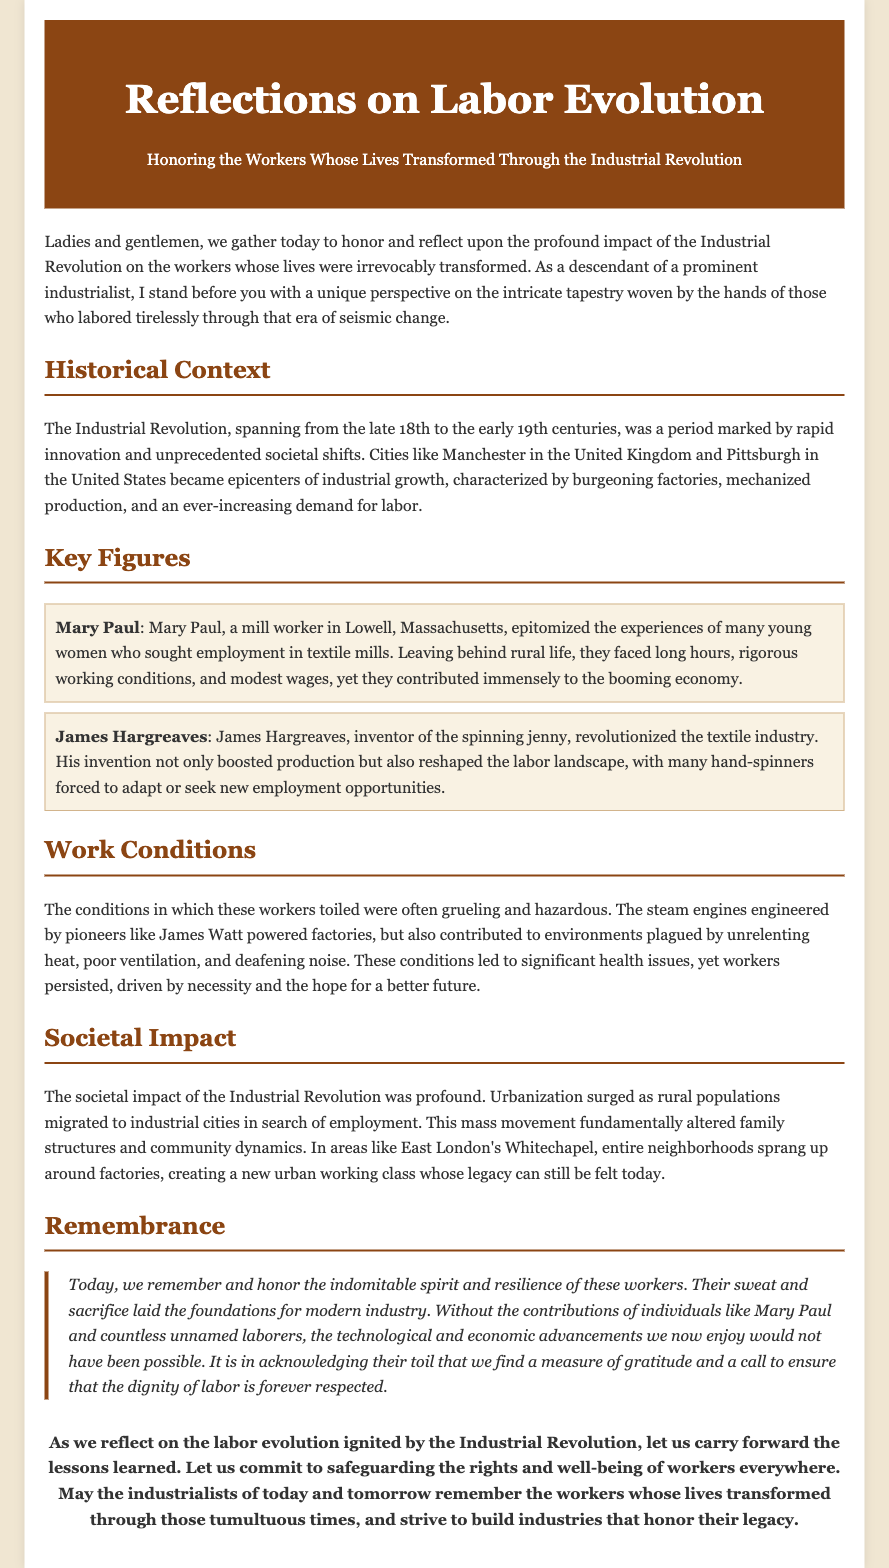What is the title of the eulogy? The title is the main heading of the document, reflecting its focus on labor and the Industrial Revolution.
Answer: Reflections on Labor Evolution Who is mentioned as a key figure from Lowell, Massachusetts? This question pertains to a specific individual highlighted in the key figures section of the eulogy.
Answer: Mary Paul What invention did James Hargreaves create? This question asks for the specific name of the invention described in relation to its impact on the textile industry.
Answer: Spinning jenny What era does the Industrial Revolution span? This question seeks to identify the time frame discussed in the historical context section.
Answer: Late 18th to early 19th centuries What major societal change occurred due to the Industrial Revolution? This question looks for a significant outcome mentioned in the societal impact section of the eulogy.
Answer: Urbanization What type of working conditions did industrial workers face? This question refers to the description of the environment in which workers labored, emphasizing the challenges they endured.
Answer: Grueling and hazardous What does the eulogy call upon us to do? This question focuses on the conclusion of the eulogy, exploring its intended message for the audience.
Answer: Safeguarding the rights and well-being of workers What is the sentiment expressed towards the contributions of workers? This question explores the emotional tone conveyed regarding the sacrifices made by workers during the Industrial Revolution.
Answer: Gratitude and respect 